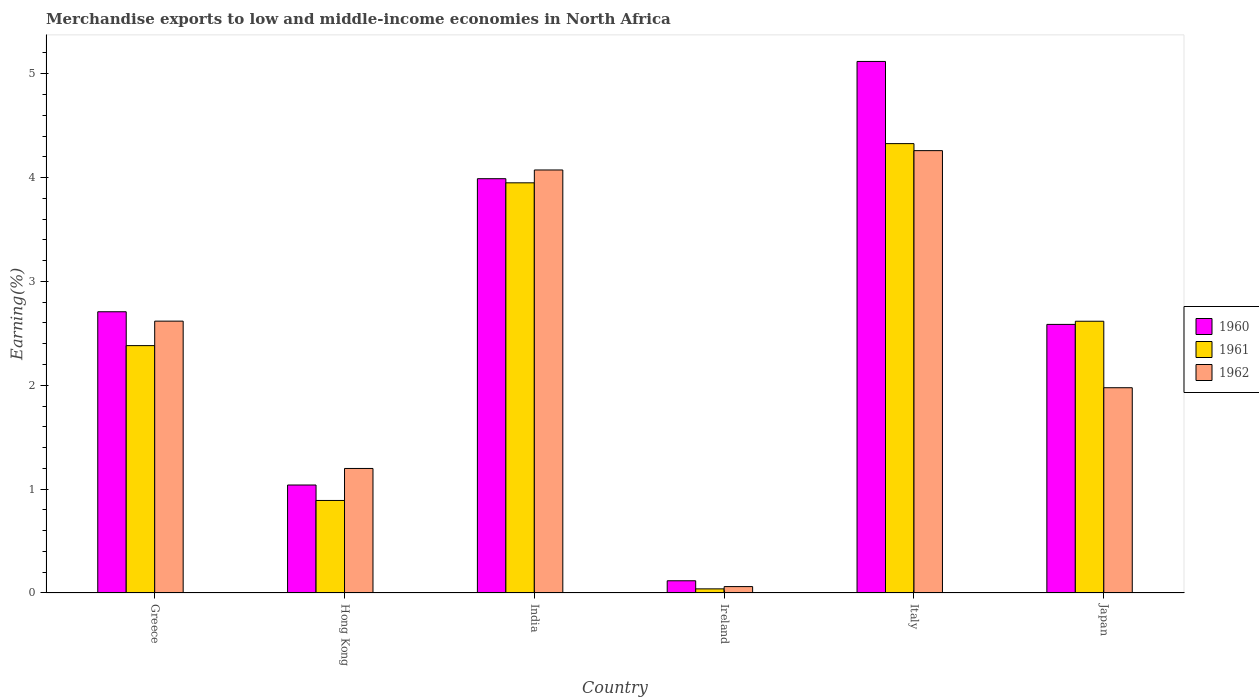Are the number of bars on each tick of the X-axis equal?
Provide a succinct answer. Yes. How many bars are there on the 1st tick from the right?
Offer a very short reply. 3. What is the label of the 6th group of bars from the left?
Offer a terse response. Japan. What is the percentage of amount earned from merchandise exports in 1962 in Ireland?
Offer a very short reply. 0.06. Across all countries, what is the maximum percentage of amount earned from merchandise exports in 1961?
Your answer should be very brief. 4.33. Across all countries, what is the minimum percentage of amount earned from merchandise exports in 1960?
Give a very brief answer. 0.12. In which country was the percentage of amount earned from merchandise exports in 1962 maximum?
Provide a succinct answer. Italy. In which country was the percentage of amount earned from merchandise exports in 1961 minimum?
Give a very brief answer. Ireland. What is the total percentage of amount earned from merchandise exports in 1960 in the graph?
Your answer should be compact. 15.56. What is the difference between the percentage of amount earned from merchandise exports in 1962 in Hong Kong and that in Italy?
Offer a very short reply. -3.06. What is the difference between the percentage of amount earned from merchandise exports in 1962 in Ireland and the percentage of amount earned from merchandise exports in 1961 in Hong Kong?
Offer a very short reply. -0.83. What is the average percentage of amount earned from merchandise exports in 1960 per country?
Make the answer very short. 2.59. What is the difference between the percentage of amount earned from merchandise exports of/in 1960 and percentage of amount earned from merchandise exports of/in 1961 in Ireland?
Give a very brief answer. 0.08. What is the ratio of the percentage of amount earned from merchandise exports in 1961 in Greece to that in Italy?
Make the answer very short. 0.55. Is the difference between the percentage of amount earned from merchandise exports in 1960 in India and Italy greater than the difference between the percentage of amount earned from merchandise exports in 1961 in India and Italy?
Your answer should be compact. No. What is the difference between the highest and the second highest percentage of amount earned from merchandise exports in 1962?
Offer a very short reply. -1.64. What is the difference between the highest and the lowest percentage of amount earned from merchandise exports in 1962?
Give a very brief answer. 4.2. In how many countries, is the percentage of amount earned from merchandise exports in 1962 greater than the average percentage of amount earned from merchandise exports in 1962 taken over all countries?
Provide a short and direct response. 3. Is it the case that in every country, the sum of the percentage of amount earned from merchandise exports in 1960 and percentage of amount earned from merchandise exports in 1961 is greater than the percentage of amount earned from merchandise exports in 1962?
Give a very brief answer. Yes. Are all the bars in the graph horizontal?
Your answer should be compact. No. How many countries are there in the graph?
Offer a very short reply. 6. Are the values on the major ticks of Y-axis written in scientific E-notation?
Your answer should be compact. No. How many legend labels are there?
Make the answer very short. 3. What is the title of the graph?
Provide a short and direct response. Merchandise exports to low and middle-income economies in North Africa. Does "1975" appear as one of the legend labels in the graph?
Keep it short and to the point. No. What is the label or title of the Y-axis?
Keep it short and to the point. Earning(%). What is the Earning(%) of 1960 in Greece?
Provide a succinct answer. 2.71. What is the Earning(%) in 1961 in Greece?
Your response must be concise. 2.38. What is the Earning(%) of 1962 in Greece?
Give a very brief answer. 2.62. What is the Earning(%) in 1960 in Hong Kong?
Ensure brevity in your answer.  1.04. What is the Earning(%) in 1961 in Hong Kong?
Your answer should be compact. 0.89. What is the Earning(%) of 1962 in Hong Kong?
Offer a very short reply. 1.2. What is the Earning(%) of 1960 in India?
Your answer should be very brief. 3.99. What is the Earning(%) of 1961 in India?
Your answer should be compact. 3.95. What is the Earning(%) in 1962 in India?
Your answer should be very brief. 4.07. What is the Earning(%) of 1960 in Ireland?
Provide a short and direct response. 0.12. What is the Earning(%) of 1961 in Ireland?
Your answer should be very brief. 0.04. What is the Earning(%) in 1962 in Ireland?
Offer a very short reply. 0.06. What is the Earning(%) in 1960 in Italy?
Keep it short and to the point. 5.12. What is the Earning(%) of 1961 in Italy?
Your answer should be very brief. 4.33. What is the Earning(%) in 1962 in Italy?
Offer a very short reply. 4.26. What is the Earning(%) in 1960 in Japan?
Offer a very short reply. 2.59. What is the Earning(%) of 1961 in Japan?
Provide a succinct answer. 2.62. What is the Earning(%) of 1962 in Japan?
Offer a very short reply. 1.98. Across all countries, what is the maximum Earning(%) of 1960?
Your answer should be compact. 5.12. Across all countries, what is the maximum Earning(%) in 1961?
Offer a terse response. 4.33. Across all countries, what is the maximum Earning(%) of 1962?
Your response must be concise. 4.26. Across all countries, what is the minimum Earning(%) in 1960?
Make the answer very short. 0.12. Across all countries, what is the minimum Earning(%) in 1961?
Provide a succinct answer. 0.04. Across all countries, what is the minimum Earning(%) of 1962?
Offer a terse response. 0.06. What is the total Earning(%) in 1960 in the graph?
Provide a short and direct response. 15.56. What is the total Earning(%) of 1961 in the graph?
Offer a very short reply. 14.21. What is the total Earning(%) of 1962 in the graph?
Ensure brevity in your answer.  14.19. What is the difference between the Earning(%) in 1960 in Greece and that in Hong Kong?
Give a very brief answer. 1.67. What is the difference between the Earning(%) of 1961 in Greece and that in Hong Kong?
Make the answer very short. 1.49. What is the difference between the Earning(%) of 1962 in Greece and that in Hong Kong?
Provide a succinct answer. 1.42. What is the difference between the Earning(%) of 1960 in Greece and that in India?
Your answer should be very brief. -1.28. What is the difference between the Earning(%) in 1961 in Greece and that in India?
Provide a succinct answer. -1.57. What is the difference between the Earning(%) of 1962 in Greece and that in India?
Provide a short and direct response. -1.46. What is the difference between the Earning(%) of 1960 in Greece and that in Ireland?
Your answer should be very brief. 2.59. What is the difference between the Earning(%) in 1961 in Greece and that in Ireland?
Keep it short and to the point. 2.34. What is the difference between the Earning(%) in 1962 in Greece and that in Ireland?
Provide a short and direct response. 2.56. What is the difference between the Earning(%) in 1960 in Greece and that in Italy?
Give a very brief answer. -2.41. What is the difference between the Earning(%) in 1961 in Greece and that in Italy?
Your response must be concise. -1.95. What is the difference between the Earning(%) of 1962 in Greece and that in Italy?
Provide a succinct answer. -1.64. What is the difference between the Earning(%) of 1960 in Greece and that in Japan?
Your answer should be compact. 0.12. What is the difference between the Earning(%) in 1961 in Greece and that in Japan?
Your response must be concise. -0.23. What is the difference between the Earning(%) of 1962 in Greece and that in Japan?
Ensure brevity in your answer.  0.64. What is the difference between the Earning(%) of 1960 in Hong Kong and that in India?
Provide a succinct answer. -2.95. What is the difference between the Earning(%) in 1961 in Hong Kong and that in India?
Offer a terse response. -3.06. What is the difference between the Earning(%) in 1962 in Hong Kong and that in India?
Keep it short and to the point. -2.87. What is the difference between the Earning(%) in 1960 in Hong Kong and that in Ireland?
Offer a very short reply. 0.92. What is the difference between the Earning(%) in 1961 in Hong Kong and that in Ireland?
Your response must be concise. 0.85. What is the difference between the Earning(%) in 1962 in Hong Kong and that in Ireland?
Give a very brief answer. 1.14. What is the difference between the Earning(%) of 1960 in Hong Kong and that in Italy?
Provide a short and direct response. -4.08. What is the difference between the Earning(%) of 1961 in Hong Kong and that in Italy?
Provide a short and direct response. -3.44. What is the difference between the Earning(%) in 1962 in Hong Kong and that in Italy?
Provide a succinct answer. -3.06. What is the difference between the Earning(%) of 1960 in Hong Kong and that in Japan?
Your answer should be compact. -1.55. What is the difference between the Earning(%) in 1961 in Hong Kong and that in Japan?
Provide a succinct answer. -1.73. What is the difference between the Earning(%) in 1962 in Hong Kong and that in Japan?
Give a very brief answer. -0.78. What is the difference between the Earning(%) in 1960 in India and that in Ireland?
Offer a very short reply. 3.87. What is the difference between the Earning(%) of 1961 in India and that in Ireland?
Your answer should be very brief. 3.91. What is the difference between the Earning(%) in 1962 in India and that in Ireland?
Your response must be concise. 4.01. What is the difference between the Earning(%) of 1960 in India and that in Italy?
Give a very brief answer. -1.13. What is the difference between the Earning(%) of 1961 in India and that in Italy?
Provide a short and direct response. -0.38. What is the difference between the Earning(%) in 1962 in India and that in Italy?
Give a very brief answer. -0.19. What is the difference between the Earning(%) in 1960 in India and that in Japan?
Give a very brief answer. 1.4. What is the difference between the Earning(%) of 1961 in India and that in Japan?
Your answer should be compact. 1.33. What is the difference between the Earning(%) in 1962 in India and that in Japan?
Offer a terse response. 2.1. What is the difference between the Earning(%) in 1960 in Ireland and that in Italy?
Your answer should be compact. -5. What is the difference between the Earning(%) of 1961 in Ireland and that in Italy?
Keep it short and to the point. -4.29. What is the difference between the Earning(%) in 1962 in Ireland and that in Italy?
Offer a very short reply. -4.2. What is the difference between the Earning(%) in 1960 in Ireland and that in Japan?
Provide a short and direct response. -2.47. What is the difference between the Earning(%) in 1961 in Ireland and that in Japan?
Make the answer very short. -2.58. What is the difference between the Earning(%) of 1962 in Ireland and that in Japan?
Provide a succinct answer. -1.91. What is the difference between the Earning(%) of 1960 in Italy and that in Japan?
Give a very brief answer. 2.53. What is the difference between the Earning(%) of 1961 in Italy and that in Japan?
Your answer should be very brief. 1.71. What is the difference between the Earning(%) in 1962 in Italy and that in Japan?
Give a very brief answer. 2.28. What is the difference between the Earning(%) in 1960 in Greece and the Earning(%) in 1961 in Hong Kong?
Give a very brief answer. 1.82. What is the difference between the Earning(%) of 1960 in Greece and the Earning(%) of 1962 in Hong Kong?
Keep it short and to the point. 1.51. What is the difference between the Earning(%) of 1961 in Greece and the Earning(%) of 1962 in Hong Kong?
Provide a succinct answer. 1.18. What is the difference between the Earning(%) in 1960 in Greece and the Earning(%) in 1961 in India?
Provide a short and direct response. -1.24. What is the difference between the Earning(%) of 1960 in Greece and the Earning(%) of 1962 in India?
Provide a short and direct response. -1.37. What is the difference between the Earning(%) of 1961 in Greece and the Earning(%) of 1962 in India?
Keep it short and to the point. -1.69. What is the difference between the Earning(%) in 1960 in Greece and the Earning(%) in 1961 in Ireland?
Offer a terse response. 2.67. What is the difference between the Earning(%) in 1960 in Greece and the Earning(%) in 1962 in Ireland?
Ensure brevity in your answer.  2.65. What is the difference between the Earning(%) of 1961 in Greece and the Earning(%) of 1962 in Ireland?
Keep it short and to the point. 2.32. What is the difference between the Earning(%) of 1960 in Greece and the Earning(%) of 1961 in Italy?
Provide a short and direct response. -1.62. What is the difference between the Earning(%) of 1960 in Greece and the Earning(%) of 1962 in Italy?
Keep it short and to the point. -1.55. What is the difference between the Earning(%) of 1961 in Greece and the Earning(%) of 1962 in Italy?
Provide a short and direct response. -1.88. What is the difference between the Earning(%) in 1960 in Greece and the Earning(%) in 1961 in Japan?
Offer a very short reply. 0.09. What is the difference between the Earning(%) in 1960 in Greece and the Earning(%) in 1962 in Japan?
Ensure brevity in your answer.  0.73. What is the difference between the Earning(%) of 1961 in Greece and the Earning(%) of 1962 in Japan?
Your answer should be compact. 0.41. What is the difference between the Earning(%) of 1960 in Hong Kong and the Earning(%) of 1961 in India?
Give a very brief answer. -2.91. What is the difference between the Earning(%) of 1960 in Hong Kong and the Earning(%) of 1962 in India?
Offer a very short reply. -3.03. What is the difference between the Earning(%) in 1961 in Hong Kong and the Earning(%) in 1962 in India?
Offer a very short reply. -3.18. What is the difference between the Earning(%) of 1960 in Hong Kong and the Earning(%) of 1961 in Ireland?
Ensure brevity in your answer.  1. What is the difference between the Earning(%) in 1960 in Hong Kong and the Earning(%) in 1962 in Ireland?
Make the answer very short. 0.98. What is the difference between the Earning(%) of 1961 in Hong Kong and the Earning(%) of 1962 in Ireland?
Your response must be concise. 0.83. What is the difference between the Earning(%) in 1960 in Hong Kong and the Earning(%) in 1961 in Italy?
Ensure brevity in your answer.  -3.29. What is the difference between the Earning(%) in 1960 in Hong Kong and the Earning(%) in 1962 in Italy?
Keep it short and to the point. -3.22. What is the difference between the Earning(%) in 1961 in Hong Kong and the Earning(%) in 1962 in Italy?
Keep it short and to the point. -3.37. What is the difference between the Earning(%) of 1960 in Hong Kong and the Earning(%) of 1961 in Japan?
Your answer should be compact. -1.58. What is the difference between the Earning(%) of 1960 in Hong Kong and the Earning(%) of 1962 in Japan?
Your response must be concise. -0.94. What is the difference between the Earning(%) of 1961 in Hong Kong and the Earning(%) of 1962 in Japan?
Your answer should be compact. -1.09. What is the difference between the Earning(%) in 1960 in India and the Earning(%) in 1961 in Ireland?
Your answer should be very brief. 3.95. What is the difference between the Earning(%) in 1960 in India and the Earning(%) in 1962 in Ireland?
Offer a terse response. 3.93. What is the difference between the Earning(%) in 1961 in India and the Earning(%) in 1962 in Ireland?
Your answer should be compact. 3.89. What is the difference between the Earning(%) in 1960 in India and the Earning(%) in 1961 in Italy?
Your answer should be compact. -0.34. What is the difference between the Earning(%) of 1960 in India and the Earning(%) of 1962 in Italy?
Offer a very short reply. -0.27. What is the difference between the Earning(%) of 1961 in India and the Earning(%) of 1962 in Italy?
Provide a short and direct response. -0.31. What is the difference between the Earning(%) of 1960 in India and the Earning(%) of 1961 in Japan?
Give a very brief answer. 1.37. What is the difference between the Earning(%) in 1960 in India and the Earning(%) in 1962 in Japan?
Your answer should be very brief. 2.01. What is the difference between the Earning(%) in 1961 in India and the Earning(%) in 1962 in Japan?
Provide a short and direct response. 1.97. What is the difference between the Earning(%) of 1960 in Ireland and the Earning(%) of 1961 in Italy?
Give a very brief answer. -4.21. What is the difference between the Earning(%) in 1960 in Ireland and the Earning(%) in 1962 in Italy?
Make the answer very short. -4.14. What is the difference between the Earning(%) of 1961 in Ireland and the Earning(%) of 1962 in Italy?
Offer a very short reply. -4.22. What is the difference between the Earning(%) of 1960 in Ireland and the Earning(%) of 1961 in Japan?
Your answer should be very brief. -2.5. What is the difference between the Earning(%) of 1960 in Ireland and the Earning(%) of 1962 in Japan?
Make the answer very short. -1.86. What is the difference between the Earning(%) of 1961 in Ireland and the Earning(%) of 1962 in Japan?
Make the answer very short. -1.94. What is the difference between the Earning(%) in 1960 in Italy and the Earning(%) in 1961 in Japan?
Your answer should be compact. 2.5. What is the difference between the Earning(%) in 1960 in Italy and the Earning(%) in 1962 in Japan?
Keep it short and to the point. 3.14. What is the difference between the Earning(%) of 1961 in Italy and the Earning(%) of 1962 in Japan?
Make the answer very short. 2.35. What is the average Earning(%) in 1960 per country?
Provide a short and direct response. 2.59. What is the average Earning(%) of 1961 per country?
Give a very brief answer. 2.37. What is the average Earning(%) in 1962 per country?
Ensure brevity in your answer.  2.36. What is the difference between the Earning(%) of 1960 and Earning(%) of 1961 in Greece?
Ensure brevity in your answer.  0.33. What is the difference between the Earning(%) of 1960 and Earning(%) of 1962 in Greece?
Make the answer very short. 0.09. What is the difference between the Earning(%) of 1961 and Earning(%) of 1962 in Greece?
Keep it short and to the point. -0.24. What is the difference between the Earning(%) of 1960 and Earning(%) of 1961 in Hong Kong?
Provide a short and direct response. 0.15. What is the difference between the Earning(%) in 1960 and Earning(%) in 1962 in Hong Kong?
Give a very brief answer. -0.16. What is the difference between the Earning(%) in 1961 and Earning(%) in 1962 in Hong Kong?
Offer a very short reply. -0.31. What is the difference between the Earning(%) in 1960 and Earning(%) in 1961 in India?
Ensure brevity in your answer.  0.04. What is the difference between the Earning(%) of 1960 and Earning(%) of 1962 in India?
Give a very brief answer. -0.08. What is the difference between the Earning(%) of 1961 and Earning(%) of 1962 in India?
Your answer should be very brief. -0.12. What is the difference between the Earning(%) of 1960 and Earning(%) of 1961 in Ireland?
Offer a terse response. 0.08. What is the difference between the Earning(%) of 1960 and Earning(%) of 1962 in Ireland?
Offer a very short reply. 0.06. What is the difference between the Earning(%) in 1961 and Earning(%) in 1962 in Ireland?
Give a very brief answer. -0.02. What is the difference between the Earning(%) of 1960 and Earning(%) of 1961 in Italy?
Give a very brief answer. 0.79. What is the difference between the Earning(%) in 1960 and Earning(%) in 1962 in Italy?
Offer a very short reply. 0.86. What is the difference between the Earning(%) of 1961 and Earning(%) of 1962 in Italy?
Your answer should be very brief. 0.07. What is the difference between the Earning(%) of 1960 and Earning(%) of 1961 in Japan?
Make the answer very short. -0.03. What is the difference between the Earning(%) of 1960 and Earning(%) of 1962 in Japan?
Make the answer very short. 0.61. What is the difference between the Earning(%) in 1961 and Earning(%) in 1962 in Japan?
Provide a short and direct response. 0.64. What is the ratio of the Earning(%) of 1960 in Greece to that in Hong Kong?
Provide a succinct answer. 2.6. What is the ratio of the Earning(%) in 1961 in Greece to that in Hong Kong?
Offer a very short reply. 2.67. What is the ratio of the Earning(%) of 1962 in Greece to that in Hong Kong?
Your response must be concise. 2.18. What is the ratio of the Earning(%) in 1960 in Greece to that in India?
Provide a succinct answer. 0.68. What is the ratio of the Earning(%) in 1961 in Greece to that in India?
Give a very brief answer. 0.6. What is the ratio of the Earning(%) in 1962 in Greece to that in India?
Your answer should be compact. 0.64. What is the ratio of the Earning(%) of 1960 in Greece to that in Ireland?
Your answer should be very brief. 23.03. What is the ratio of the Earning(%) in 1961 in Greece to that in Ireland?
Make the answer very short. 60.05. What is the ratio of the Earning(%) of 1962 in Greece to that in Ireland?
Offer a very short reply. 42.46. What is the ratio of the Earning(%) of 1960 in Greece to that in Italy?
Give a very brief answer. 0.53. What is the ratio of the Earning(%) in 1961 in Greece to that in Italy?
Provide a succinct answer. 0.55. What is the ratio of the Earning(%) of 1962 in Greece to that in Italy?
Your answer should be compact. 0.61. What is the ratio of the Earning(%) in 1960 in Greece to that in Japan?
Ensure brevity in your answer.  1.05. What is the ratio of the Earning(%) of 1961 in Greece to that in Japan?
Make the answer very short. 0.91. What is the ratio of the Earning(%) in 1962 in Greece to that in Japan?
Give a very brief answer. 1.32. What is the ratio of the Earning(%) of 1960 in Hong Kong to that in India?
Your answer should be compact. 0.26. What is the ratio of the Earning(%) of 1961 in Hong Kong to that in India?
Provide a short and direct response. 0.23. What is the ratio of the Earning(%) of 1962 in Hong Kong to that in India?
Keep it short and to the point. 0.29. What is the ratio of the Earning(%) of 1960 in Hong Kong to that in Ireland?
Ensure brevity in your answer.  8.84. What is the ratio of the Earning(%) of 1961 in Hong Kong to that in Ireland?
Offer a very short reply. 22.46. What is the ratio of the Earning(%) in 1962 in Hong Kong to that in Ireland?
Your response must be concise. 19.45. What is the ratio of the Earning(%) in 1960 in Hong Kong to that in Italy?
Keep it short and to the point. 0.2. What is the ratio of the Earning(%) of 1961 in Hong Kong to that in Italy?
Offer a terse response. 0.21. What is the ratio of the Earning(%) in 1962 in Hong Kong to that in Italy?
Your answer should be compact. 0.28. What is the ratio of the Earning(%) in 1960 in Hong Kong to that in Japan?
Ensure brevity in your answer.  0.4. What is the ratio of the Earning(%) in 1961 in Hong Kong to that in Japan?
Keep it short and to the point. 0.34. What is the ratio of the Earning(%) of 1962 in Hong Kong to that in Japan?
Offer a terse response. 0.61. What is the ratio of the Earning(%) in 1960 in India to that in Ireland?
Your answer should be compact. 33.93. What is the ratio of the Earning(%) of 1961 in India to that in Ireland?
Keep it short and to the point. 99.57. What is the ratio of the Earning(%) of 1962 in India to that in Ireland?
Your answer should be very brief. 66.07. What is the ratio of the Earning(%) in 1960 in India to that in Italy?
Give a very brief answer. 0.78. What is the ratio of the Earning(%) of 1961 in India to that in Italy?
Offer a terse response. 0.91. What is the ratio of the Earning(%) in 1962 in India to that in Italy?
Provide a succinct answer. 0.96. What is the ratio of the Earning(%) of 1960 in India to that in Japan?
Keep it short and to the point. 1.54. What is the ratio of the Earning(%) in 1961 in India to that in Japan?
Your response must be concise. 1.51. What is the ratio of the Earning(%) in 1962 in India to that in Japan?
Make the answer very short. 2.06. What is the ratio of the Earning(%) in 1960 in Ireland to that in Italy?
Give a very brief answer. 0.02. What is the ratio of the Earning(%) of 1961 in Ireland to that in Italy?
Your response must be concise. 0.01. What is the ratio of the Earning(%) of 1962 in Ireland to that in Italy?
Your answer should be very brief. 0.01. What is the ratio of the Earning(%) in 1960 in Ireland to that in Japan?
Offer a very short reply. 0.05. What is the ratio of the Earning(%) of 1961 in Ireland to that in Japan?
Your answer should be compact. 0.02. What is the ratio of the Earning(%) in 1962 in Ireland to that in Japan?
Your answer should be compact. 0.03. What is the ratio of the Earning(%) in 1960 in Italy to that in Japan?
Your response must be concise. 1.98. What is the ratio of the Earning(%) of 1961 in Italy to that in Japan?
Ensure brevity in your answer.  1.65. What is the ratio of the Earning(%) of 1962 in Italy to that in Japan?
Provide a succinct answer. 2.16. What is the difference between the highest and the second highest Earning(%) of 1960?
Your answer should be compact. 1.13. What is the difference between the highest and the second highest Earning(%) in 1961?
Provide a succinct answer. 0.38. What is the difference between the highest and the second highest Earning(%) in 1962?
Your response must be concise. 0.19. What is the difference between the highest and the lowest Earning(%) in 1960?
Ensure brevity in your answer.  5. What is the difference between the highest and the lowest Earning(%) in 1961?
Your answer should be very brief. 4.29. What is the difference between the highest and the lowest Earning(%) in 1962?
Make the answer very short. 4.2. 